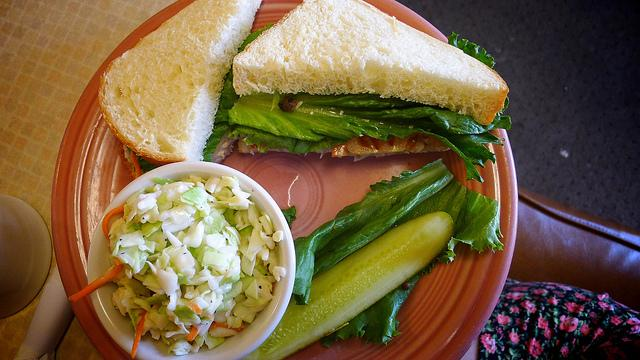From which vegetable is the main side dish sourced from mainly? Please explain your reasoning. cabbage. The side dish on the plate is cole slaw which is made of shredded cabbage. 